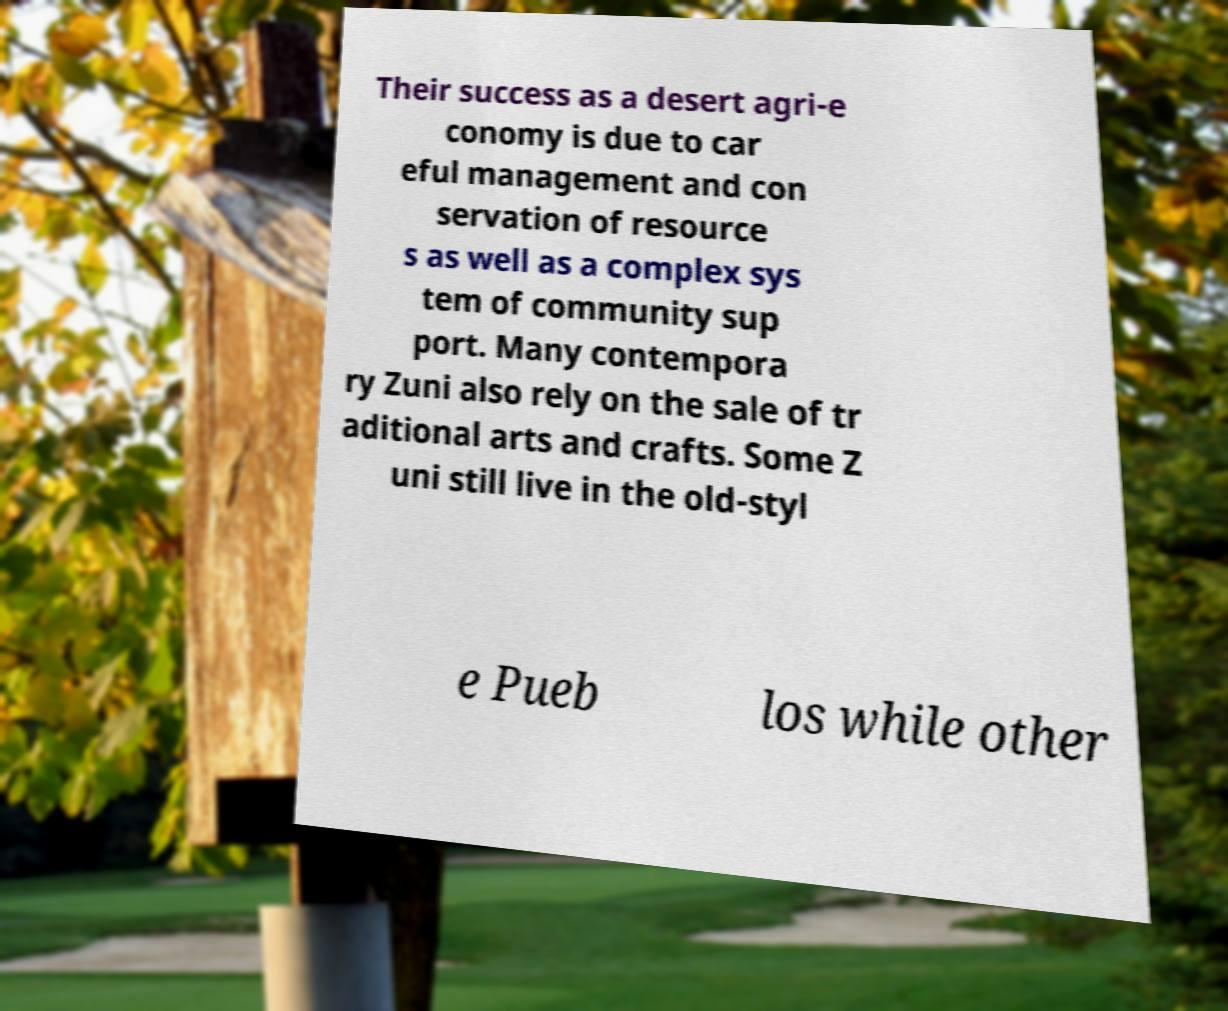Can you accurately transcribe the text from the provided image for me? Their success as a desert agri-e conomy is due to car eful management and con servation of resource s as well as a complex sys tem of community sup port. Many contempora ry Zuni also rely on the sale of tr aditional arts and crafts. Some Z uni still live in the old-styl e Pueb los while other 